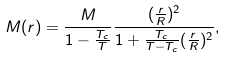<formula> <loc_0><loc_0><loc_500><loc_500>M ( r ) = \frac { M } { 1 - \frac { T _ { c } } { T } } \frac { ( \frac { r } { R } ) ^ { 2 } } { 1 + \frac { T _ { c } } { T - T _ { c } } ( \frac { r } { R } ) ^ { 2 } } ,</formula> 